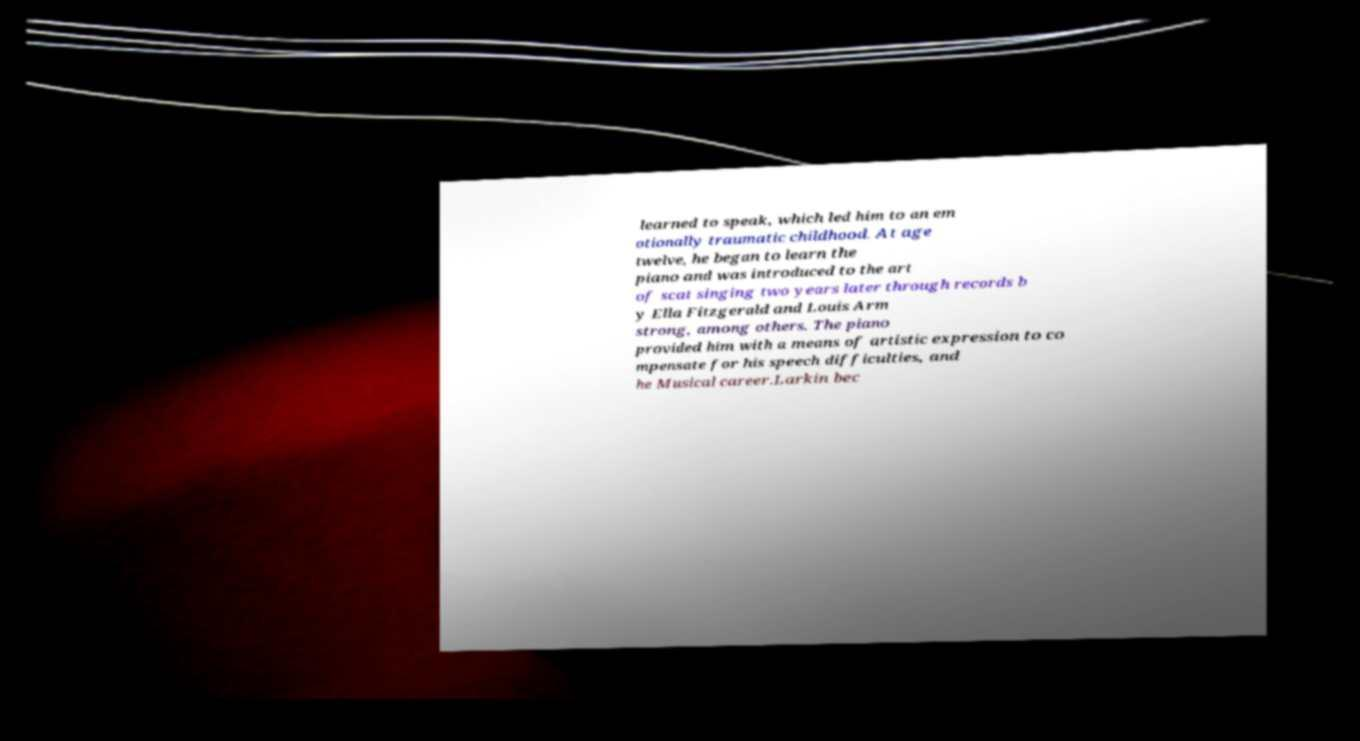What messages or text are displayed in this image? I need them in a readable, typed format. learned to speak, which led him to an em otionally traumatic childhood. At age twelve, he began to learn the piano and was introduced to the art of scat singing two years later through records b y Ella Fitzgerald and Louis Arm strong, among others. The piano provided him with a means of artistic expression to co mpensate for his speech difficulties, and he Musical career.Larkin bec 